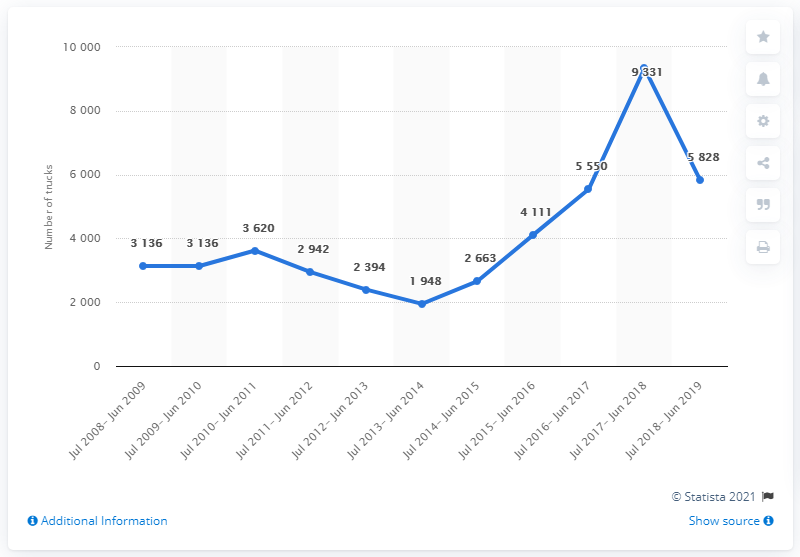Identify some key points in this picture. During the period of July 2017 to June 2019, a total of 5,828 trucks were sold in Pakistan. 